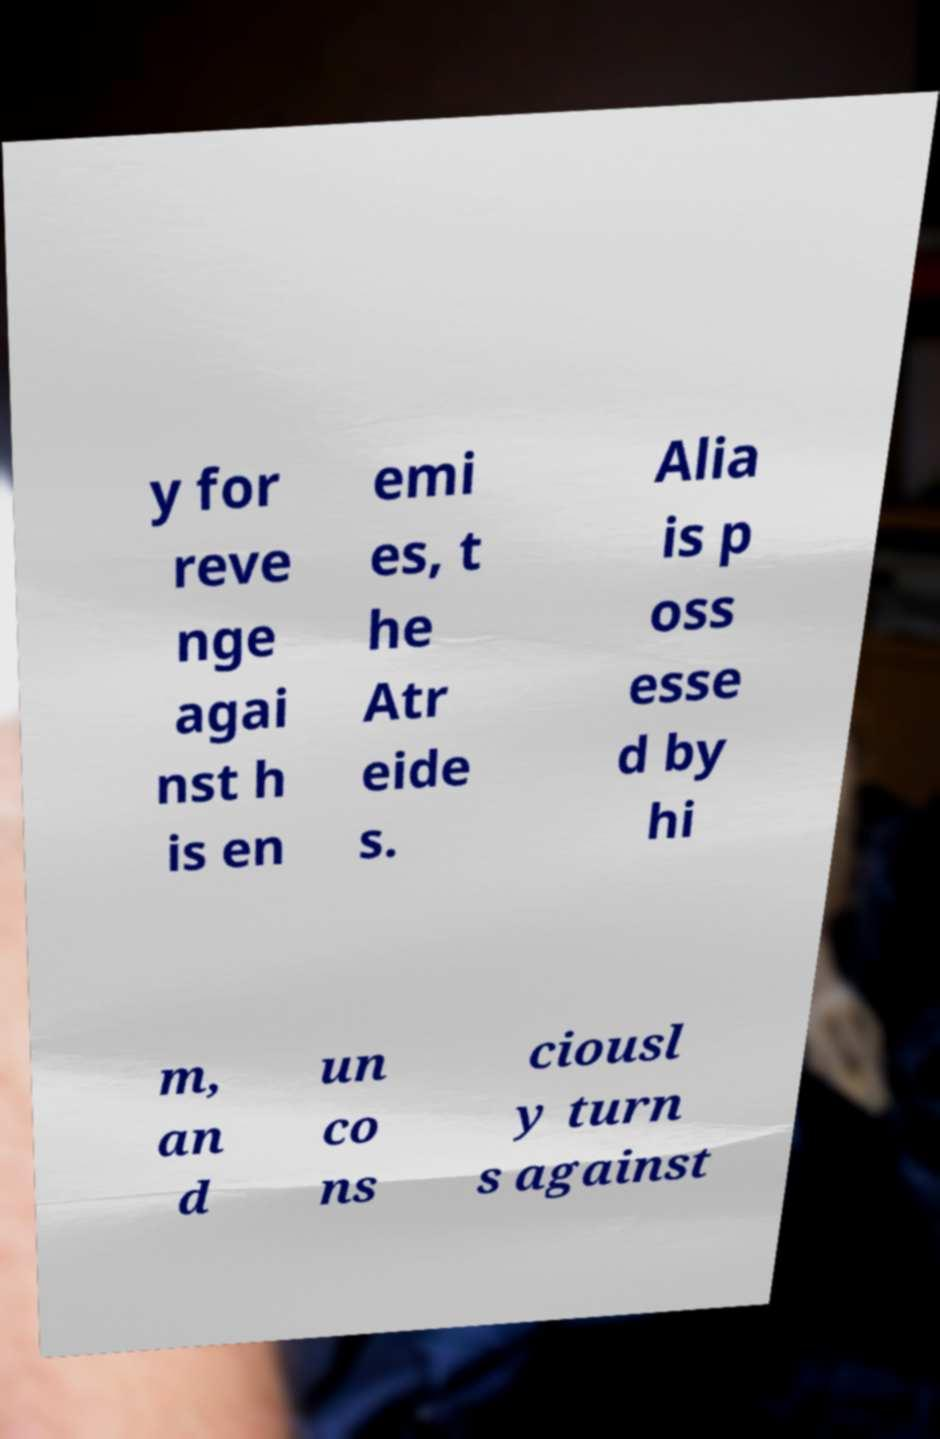I need the written content from this picture converted into text. Can you do that? y for reve nge agai nst h is en emi es, t he Atr eide s. Alia is p oss esse d by hi m, an d un co ns ciousl y turn s against 